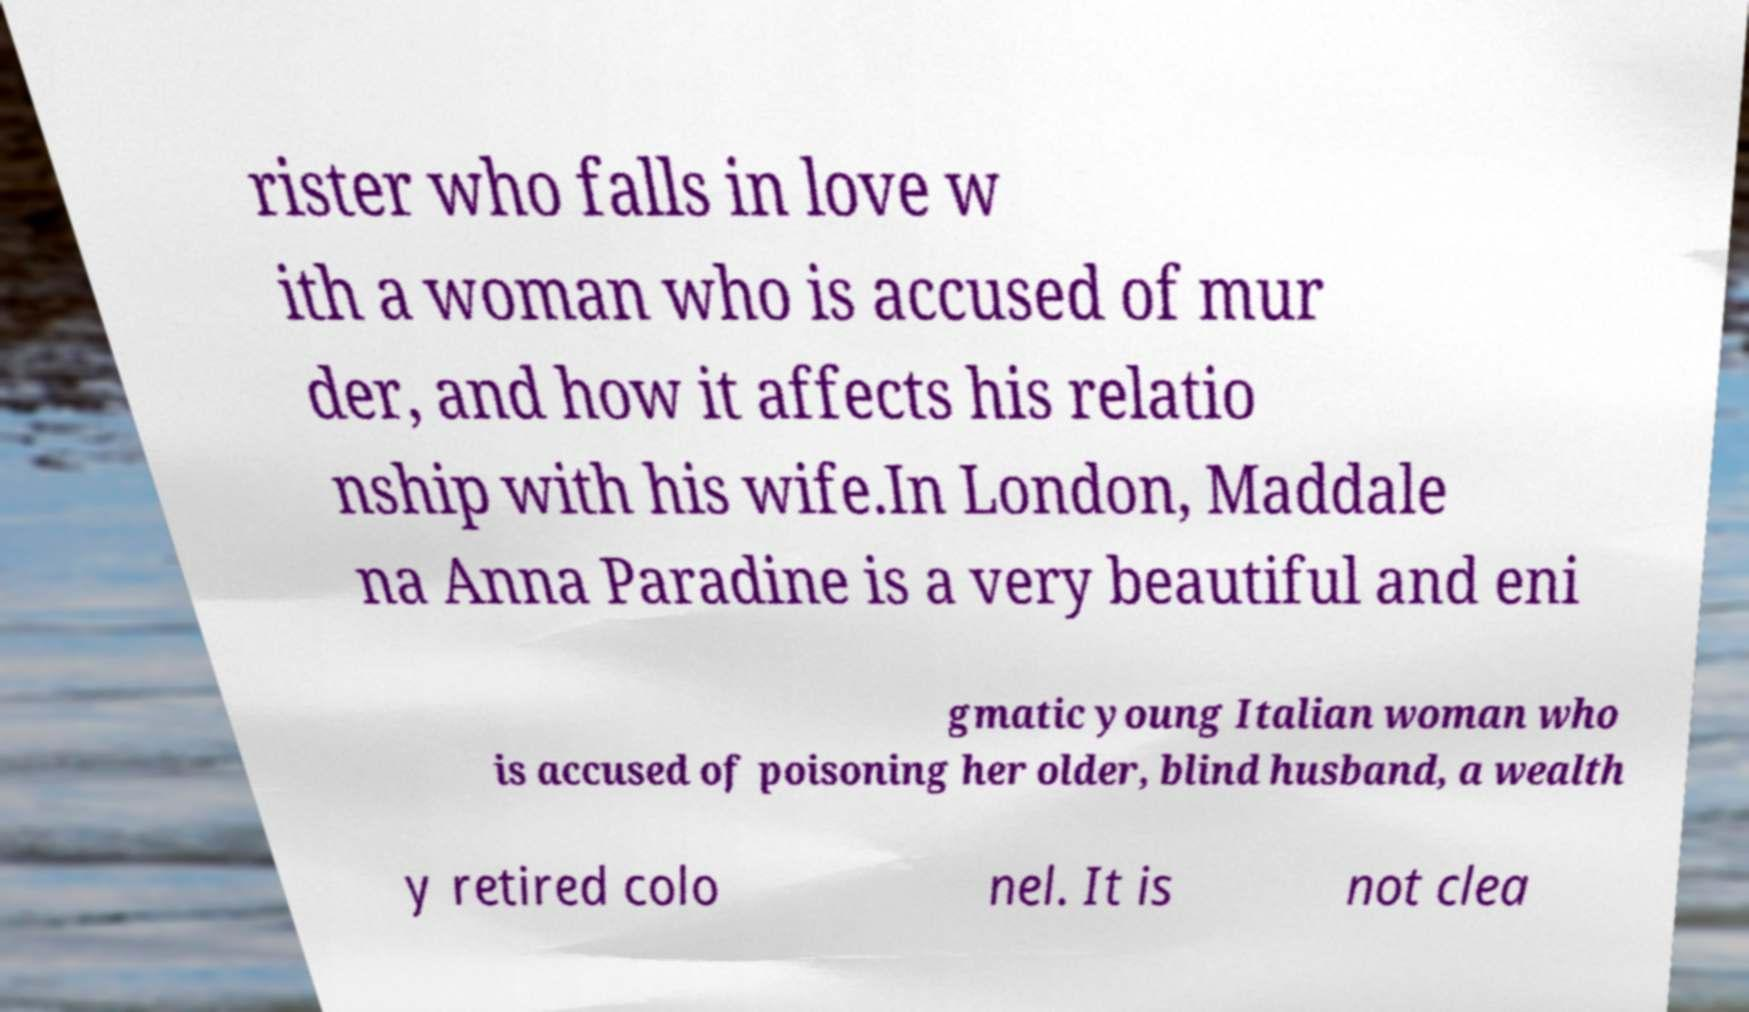Could you assist in decoding the text presented in this image and type it out clearly? rister who falls in love w ith a woman who is accused of mur der, and how it affects his relatio nship with his wife.In London, Maddale na Anna Paradine is a very beautiful and eni gmatic young Italian woman who is accused of poisoning her older, blind husband, a wealth y retired colo nel. It is not clea 